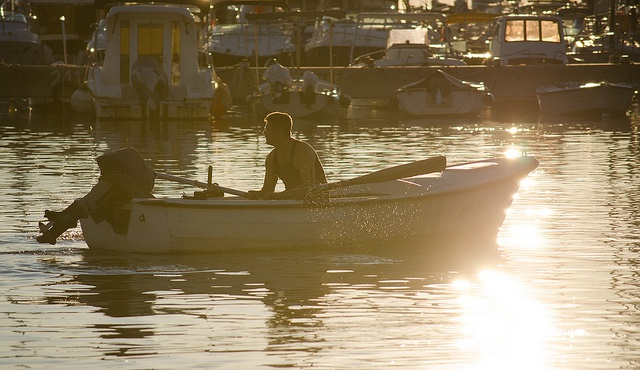Describe the objects in this image and their specific colors. I can see boat in black, olive, gray, and tan tones, boat in black, olive, and gray tones, people in black, olive, and tan tones, boat in black, gray, tan, and maroon tones, and boat in black, gray, and maroon tones in this image. 